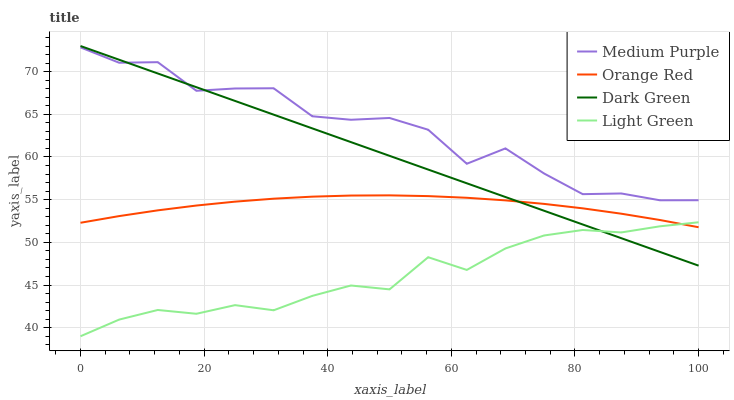Does Light Green have the minimum area under the curve?
Answer yes or no. Yes. Does Medium Purple have the maximum area under the curve?
Answer yes or no. Yes. Does Orange Red have the minimum area under the curve?
Answer yes or no. No. Does Orange Red have the maximum area under the curve?
Answer yes or no. No. Is Dark Green the smoothest?
Answer yes or no. Yes. Is Medium Purple the roughest?
Answer yes or no. Yes. Is Orange Red the smoothest?
Answer yes or no. No. Is Orange Red the roughest?
Answer yes or no. No. Does Light Green have the lowest value?
Answer yes or no. Yes. Does Orange Red have the lowest value?
Answer yes or no. No. Does Dark Green have the highest value?
Answer yes or no. Yes. Does Orange Red have the highest value?
Answer yes or no. No. Is Light Green less than Medium Purple?
Answer yes or no. Yes. Is Medium Purple greater than Orange Red?
Answer yes or no. Yes. Does Light Green intersect Dark Green?
Answer yes or no. Yes. Is Light Green less than Dark Green?
Answer yes or no. No. Is Light Green greater than Dark Green?
Answer yes or no. No. Does Light Green intersect Medium Purple?
Answer yes or no. No. 